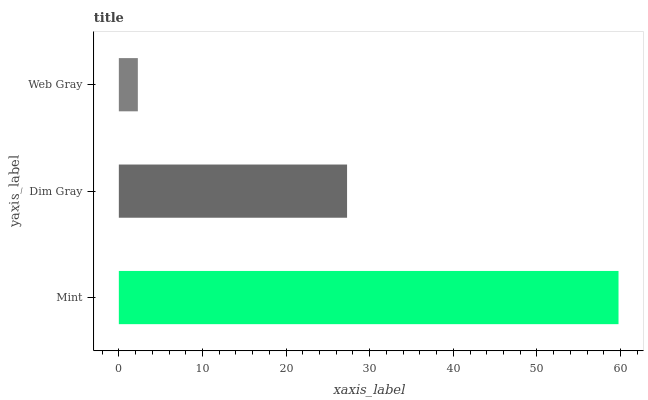Is Web Gray the minimum?
Answer yes or no. Yes. Is Mint the maximum?
Answer yes or no. Yes. Is Dim Gray the minimum?
Answer yes or no. No. Is Dim Gray the maximum?
Answer yes or no. No. Is Mint greater than Dim Gray?
Answer yes or no. Yes. Is Dim Gray less than Mint?
Answer yes or no. Yes. Is Dim Gray greater than Mint?
Answer yes or no. No. Is Mint less than Dim Gray?
Answer yes or no. No. Is Dim Gray the high median?
Answer yes or no. Yes. Is Dim Gray the low median?
Answer yes or no. Yes. Is Web Gray the high median?
Answer yes or no. No. Is Web Gray the low median?
Answer yes or no. No. 